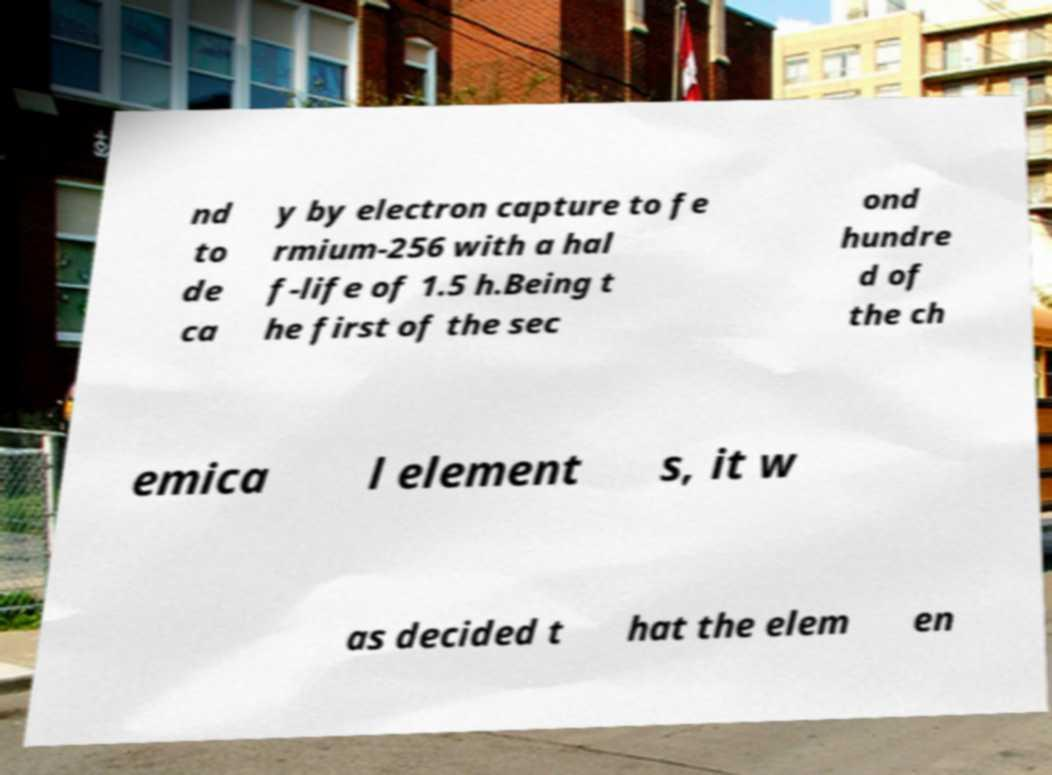There's text embedded in this image that I need extracted. Can you transcribe it verbatim? nd to de ca y by electron capture to fe rmium-256 with a hal f-life of 1.5 h.Being t he first of the sec ond hundre d of the ch emica l element s, it w as decided t hat the elem en 